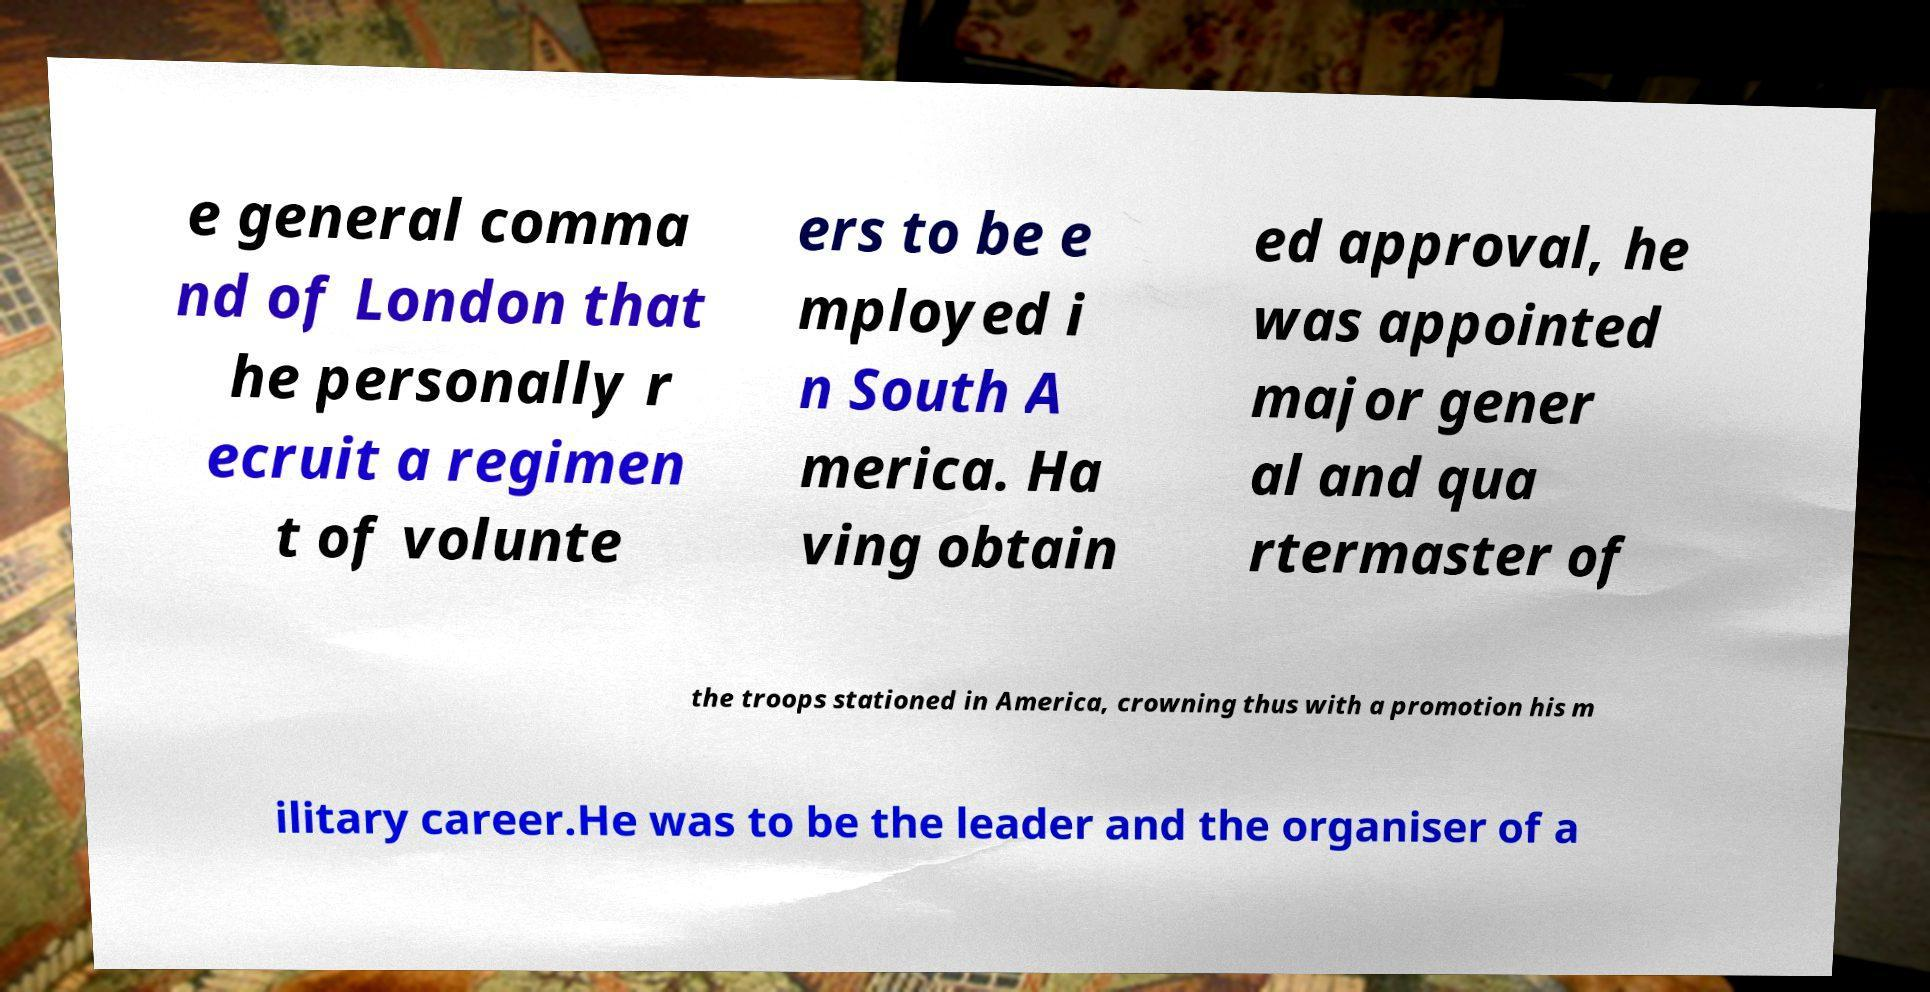Please identify and transcribe the text found in this image. e general comma nd of London that he personally r ecruit a regimen t of volunte ers to be e mployed i n South A merica. Ha ving obtain ed approval, he was appointed major gener al and qua rtermaster of the troops stationed in America, crowning thus with a promotion his m ilitary career.He was to be the leader and the organiser of a 